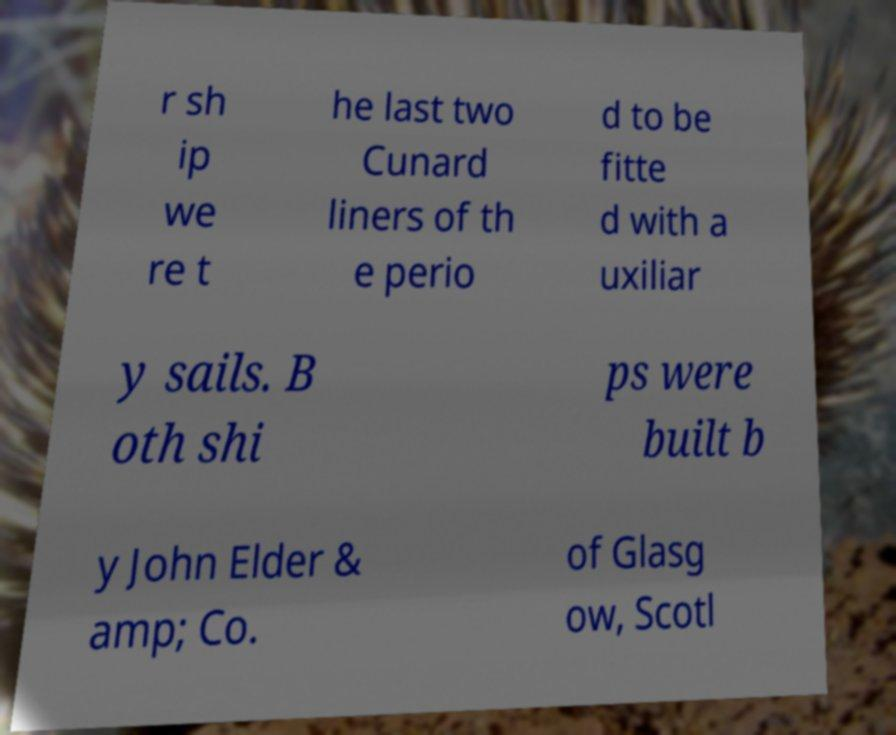Could you extract and type out the text from this image? r sh ip we re t he last two Cunard liners of th e perio d to be fitte d with a uxiliar y sails. B oth shi ps were built b y John Elder & amp; Co. of Glasg ow, Scotl 